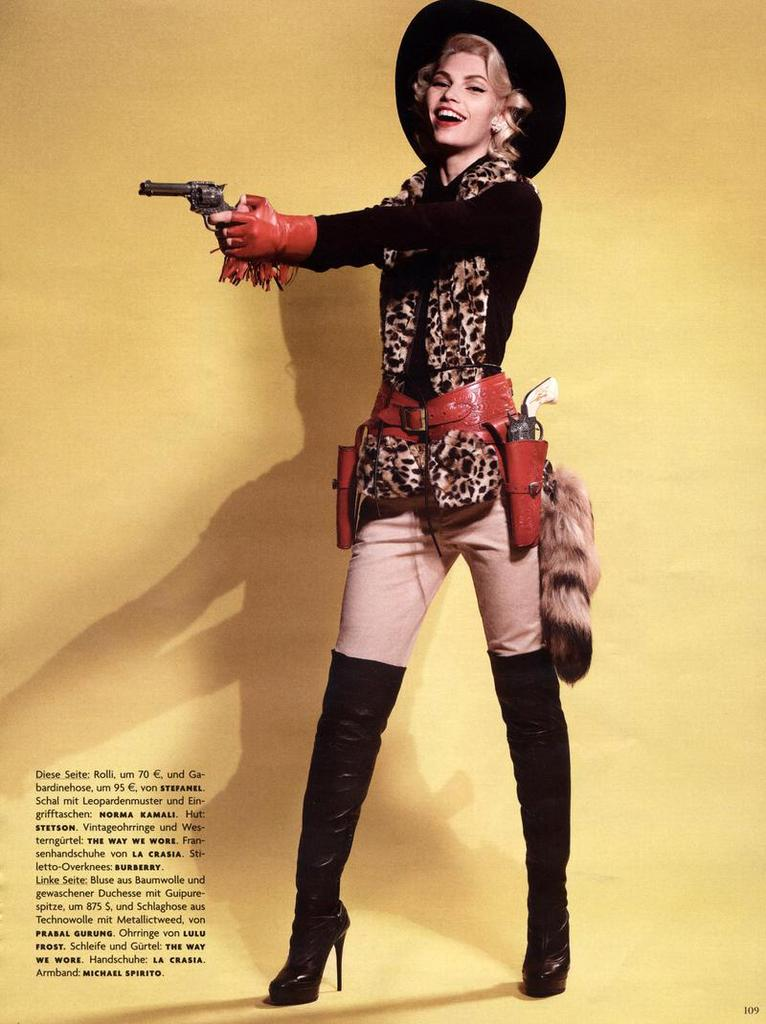What is present in the image? There is a person in the image. Can you describe the person's attire? The person is wearing clothes. What is the person holding in the image? The person is holding a gun. Is there any text visible in the image? Yes, there is text in the bottom left corner of the image. How does the person start the screw in the image? There is no screw present in the image, so it is not possible to answer that question. 